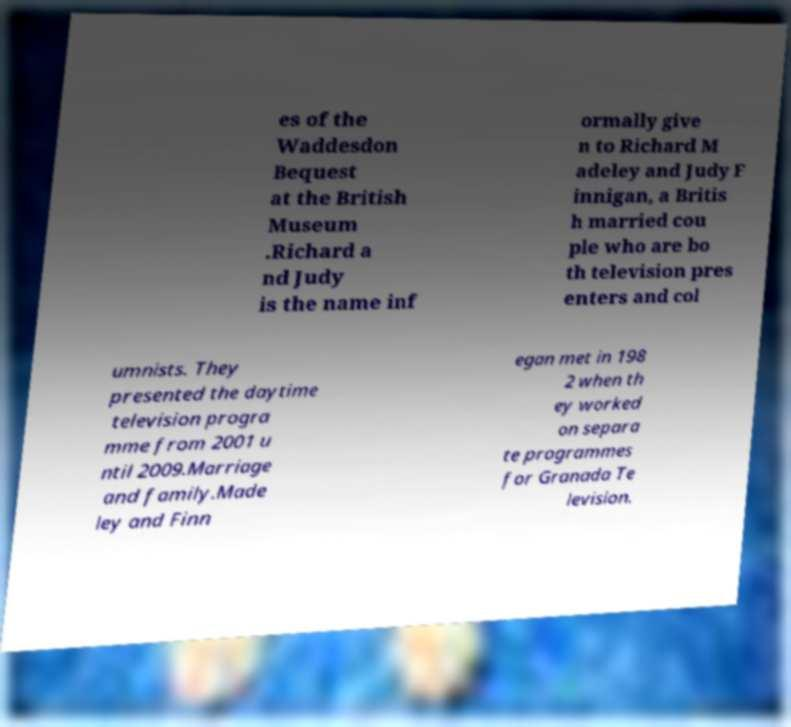Please read and relay the text visible in this image. What does it say? es of the Waddesdon Bequest at the British Museum .Richard a nd Judy is the name inf ormally give n to Richard M adeley and Judy F innigan, a Britis h married cou ple who are bo th television pres enters and col umnists. They presented the daytime television progra mme from 2001 u ntil 2009.Marriage and family.Made ley and Finn egan met in 198 2 when th ey worked on separa te programmes for Granada Te levision. 